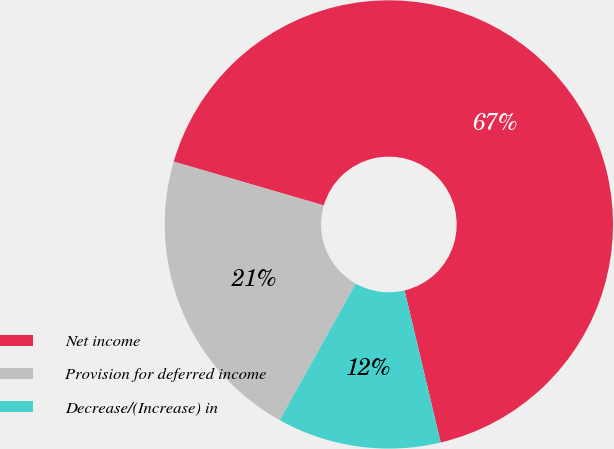Convert chart to OTSL. <chart><loc_0><loc_0><loc_500><loc_500><pie_chart><fcel>Net income<fcel>Provision for deferred income<fcel>Decrease/(Increase) in<nl><fcel>66.77%<fcel>21.42%<fcel>11.81%<nl></chart> 